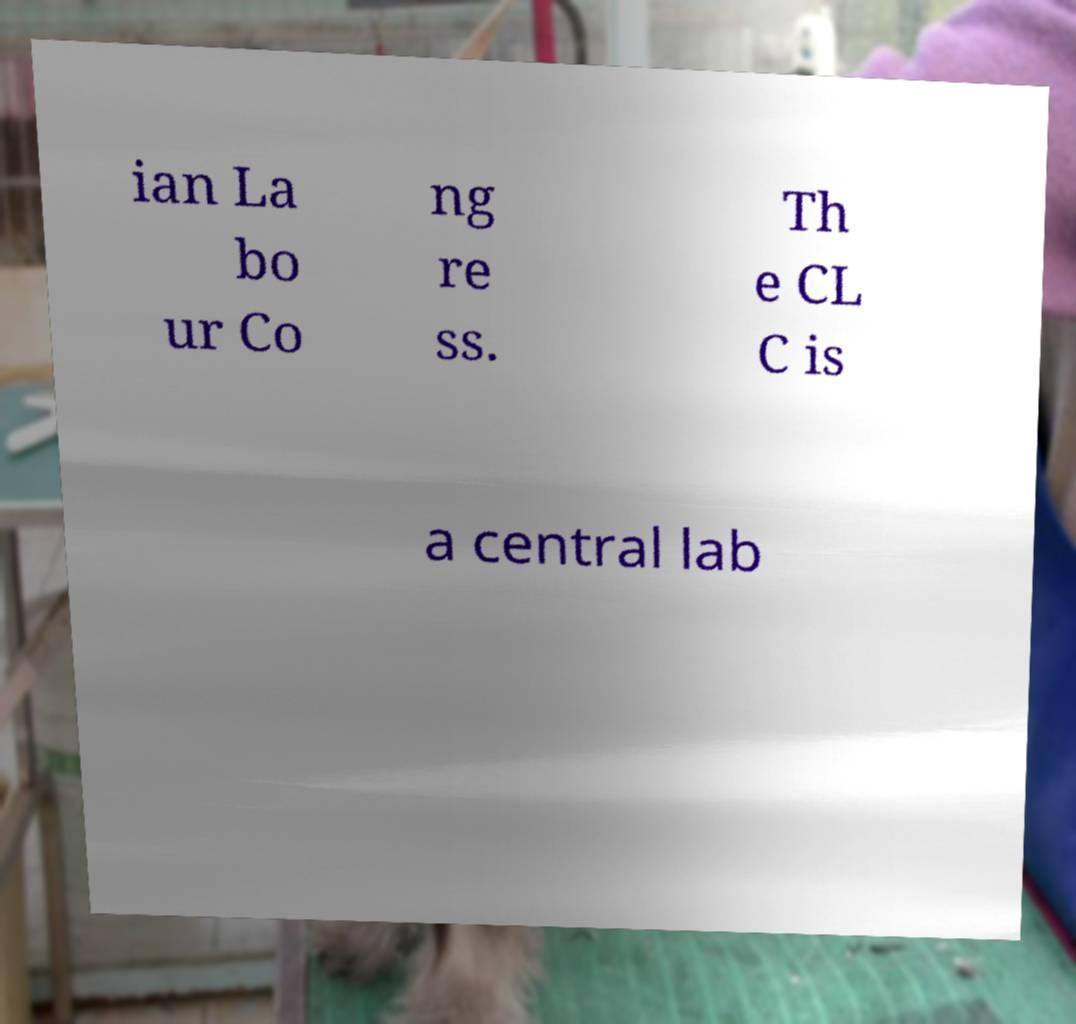For documentation purposes, I need the text within this image transcribed. Could you provide that? ian La bo ur Co ng re ss. Th e CL C is a central lab 